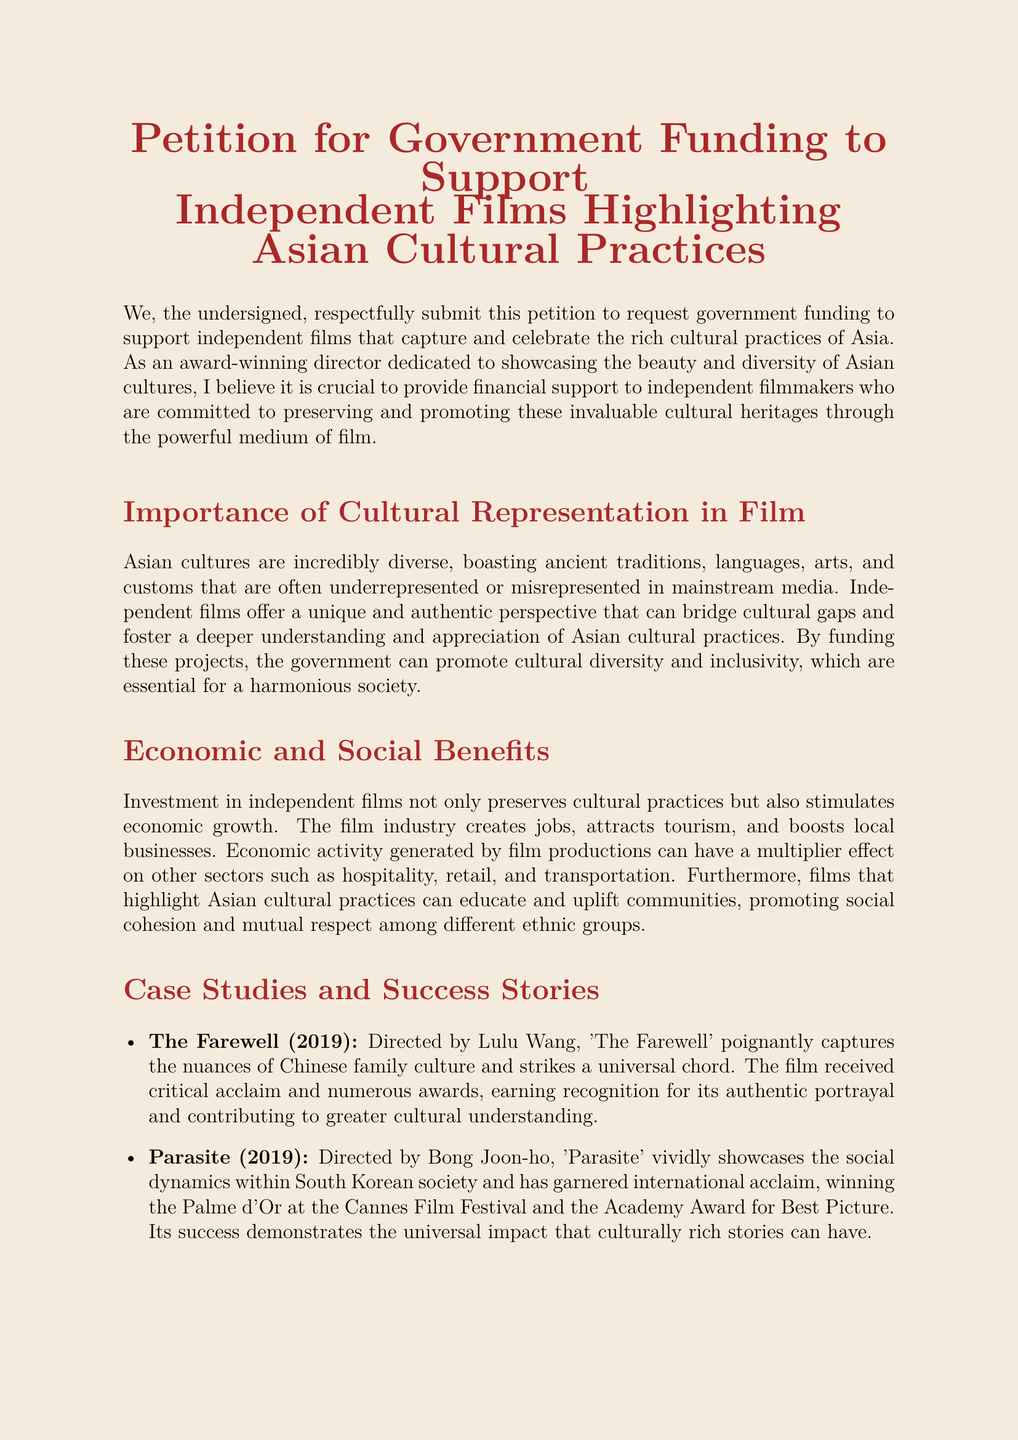What is the title of the petition? The title of the petition is given at the beginning of the document, clearly stating its purpose.
Answer: Petition for Government Funding to Support Independent Films Highlighting Asian Cultural Practices Who is the director mentioned in the petition? The petition references an award-winning director as the author, emphasizing their commitment to Asian cultural practices.
Answer: Award-winning director What is one of the case studies mentioned in the document? The petition lists several films as examples of successful independent films that highlight Asian cultures.
Answer: The Farewell What year was the film "Parasite" released? The petition includes the release year of the film "Parasite" as part of its case studies.
Answer: 2019 What is one recommendation given in the petition? The document lists specific recommendations for government action to support filmmakers.
Answer: Create Dedicated Funding Programs How do independent films benefit society, according to the petition? The petition discusses several benefits, notably regarding cultural representation and community impact.
Answer: Promote inclusivity What does the petition say about the economic impact of independent films? The petition highlights that investment in independent films can stimulate economic growth.
Answer: Stimulates economic growth Which award did "Parasite" win? The document notes the prestigious award won by the film "Parasite," which underscores its significance.
Answer: Palme d'Or 